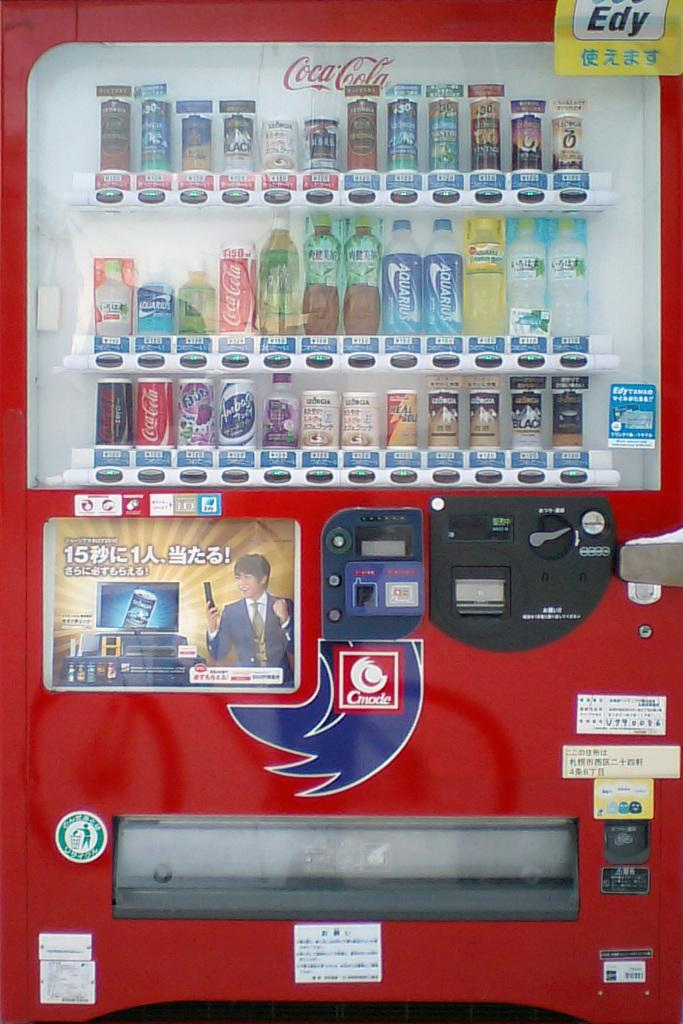<image>
Summarize the visual content of the image. a coca cola machine has lots of choices 